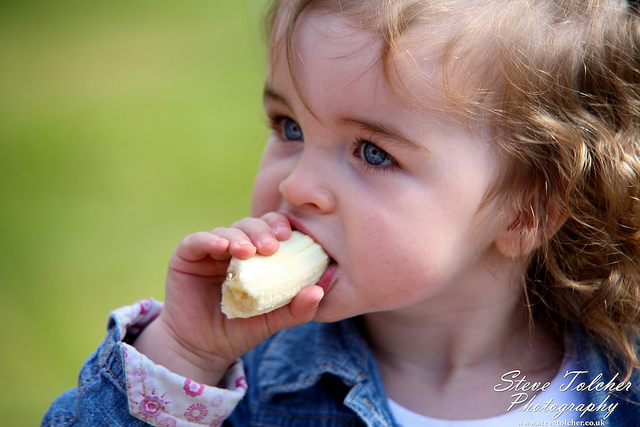Read all the text in this image. Photograpy Steve Joleher 